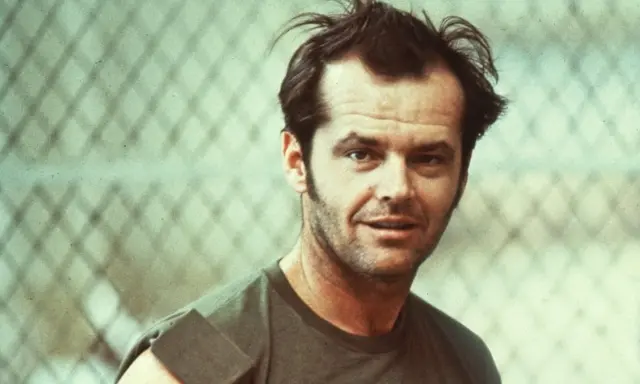This scene looks interesting. Can you come up with an adventurous plot where this person is the hero? In this adventurous plot, the man is a former detective who has been living off the grid for years. One day, he receives an anonymous letter detailing a conspiracy that threatens the city he once protected. With no one else to turn to, he makes the difficult decision to return to the city and uncover the truth. Along the way, he faces old enemies, forms new alliances, and unearths secrets that challenge everything he thought he knew. The chain-link fence he stands in front of marks the boundary between his secluded life and the chaotic world he's about to re-enter, setting the stage for a thrilling journey filled with danger, intrigue, and redemption. 